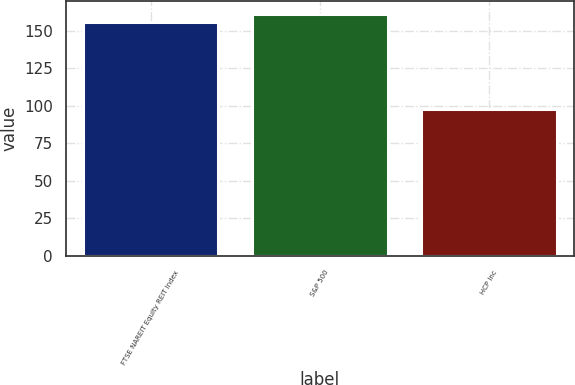Convert chart to OTSL. <chart><loc_0><loc_0><loc_500><loc_500><bar_chart><fcel>FTSE NAREIT Equity REIT Index<fcel>S&P 500<fcel>HCP Inc<nl><fcel>155.75<fcel>161.64<fcel>98.26<nl></chart> 